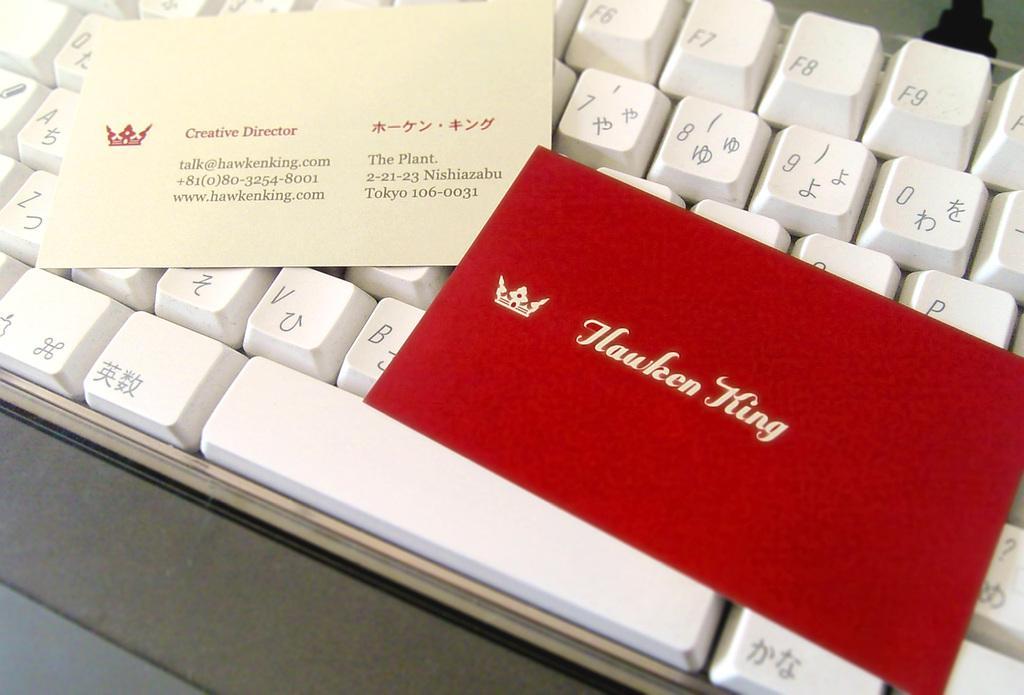Describe this image in one or two sentences. In this picture we can see couple of cards on the keyboard. 